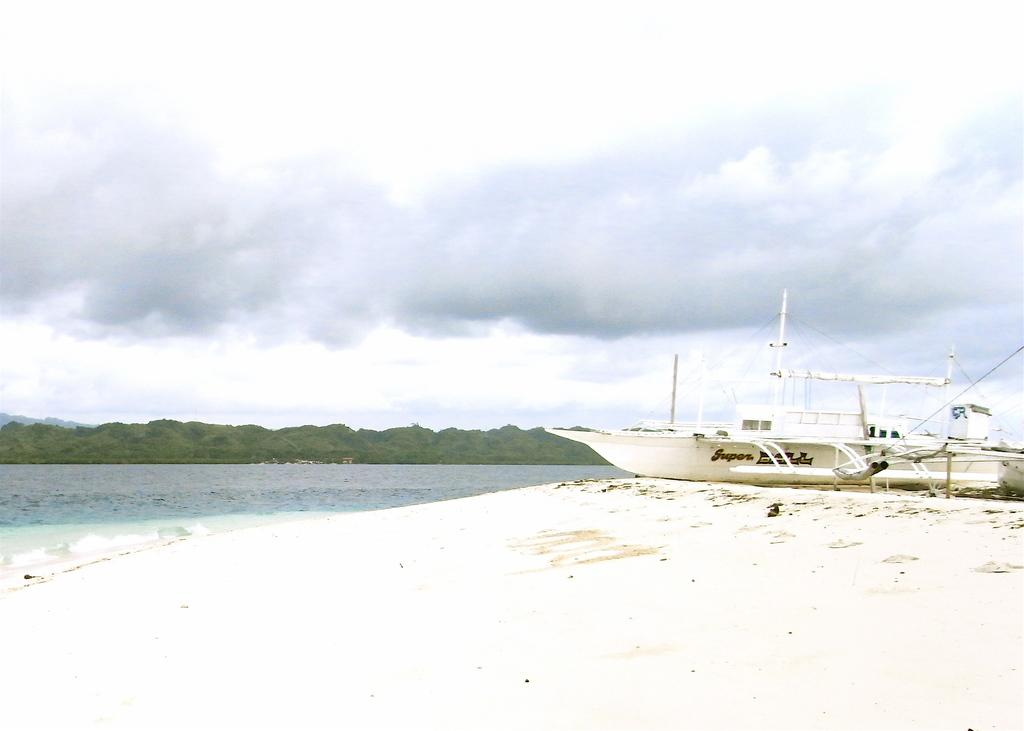What is the main subject of the image? There is a ship in the image. What is located at the bottom of the image? There is sand at the bottom of the image. What is in front of the ship? There is water in front of the ship. What can be seen in the background of the image? There are trees and the sky visible in the background of the image. What type of watch can be seen on the ship in the image? There is no watch visible on the ship in the image. How does the ship move in the image? The ship does not move in the image; it is stationary. 